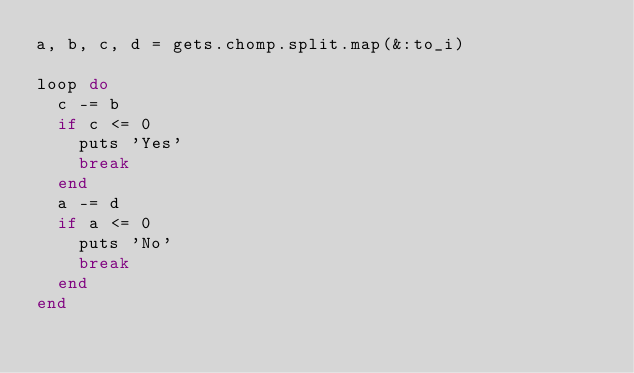<code> <loc_0><loc_0><loc_500><loc_500><_Ruby_>a, b, c, d = gets.chomp.split.map(&:to_i)

loop do
  c -= b
  if c <= 0
    puts 'Yes'
    break
  end
  a -= d
  if a <= 0
    puts 'No'
    break
  end
end</code> 